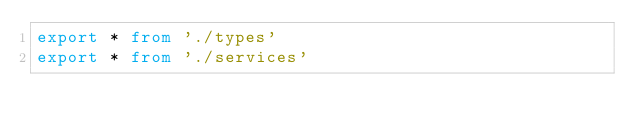Convert code to text. <code><loc_0><loc_0><loc_500><loc_500><_TypeScript_>export * from './types'
export * from './services'
</code> 